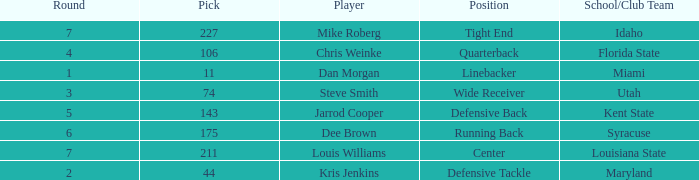Where did steve smith go to school? Utah. 